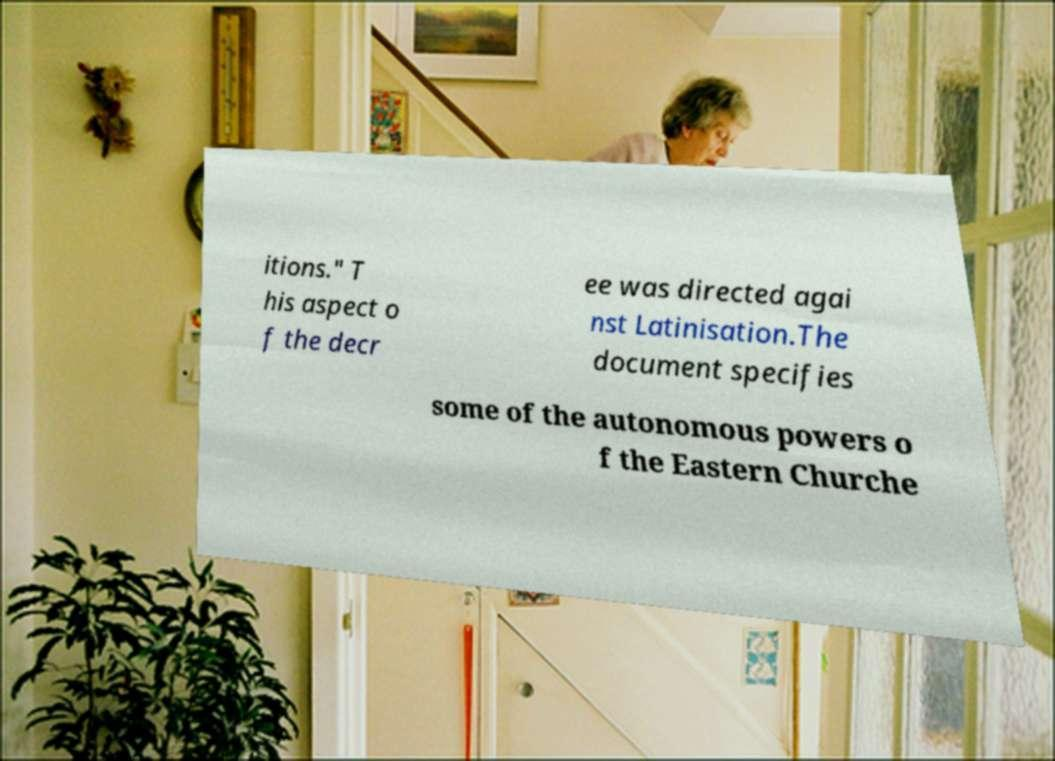Please read and relay the text visible in this image. What does it say? itions." T his aspect o f the decr ee was directed agai nst Latinisation.The document specifies some of the autonomous powers o f the Eastern Churche 